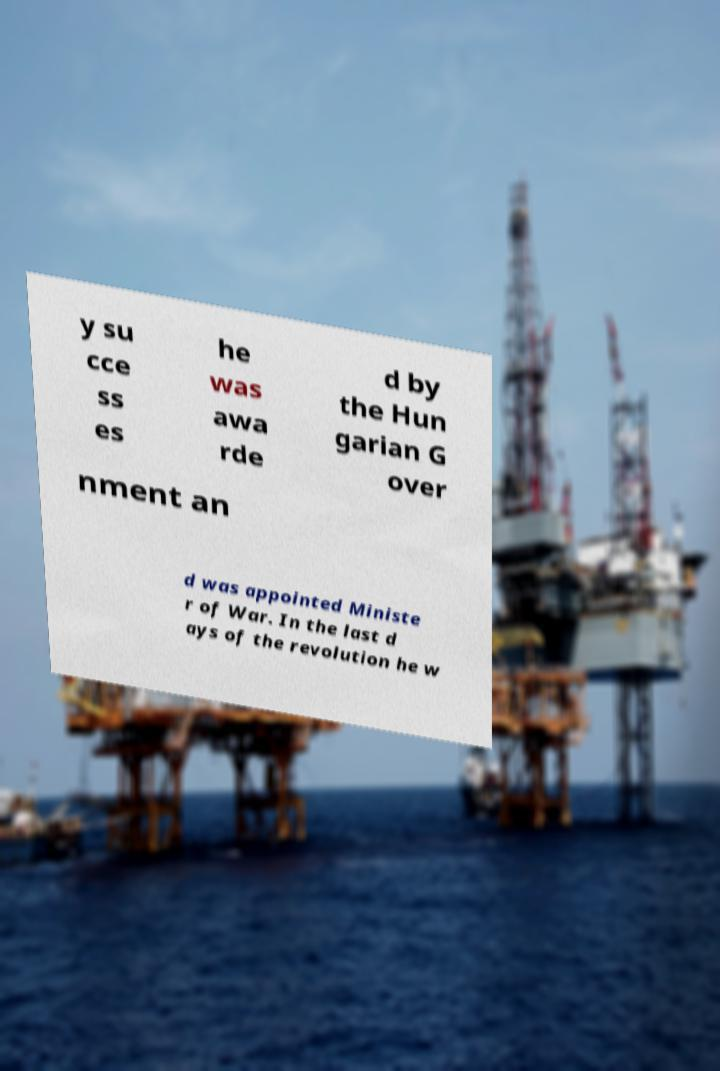There's text embedded in this image that I need extracted. Can you transcribe it verbatim? y su cce ss es he was awa rde d by the Hun garian G over nment an d was appointed Ministe r of War. In the last d ays of the revolution he w 